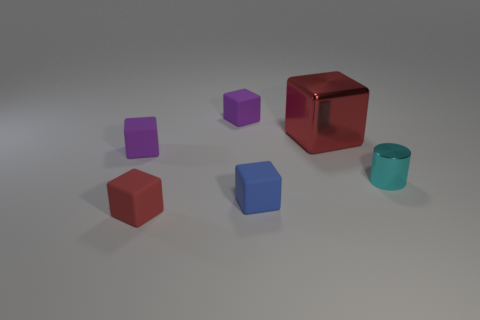Subtract all large red shiny blocks. How many blocks are left? 4 Subtract all purple cylinders. How many purple cubes are left? 2 Subtract 3 blocks. How many blocks are left? 2 Subtract all blue cubes. How many cubes are left? 4 Add 2 tiny purple matte objects. How many objects exist? 8 Subtract all blocks. How many objects are left? 1 Subtract all blue cubes. Subtract all brown cylinders. How many cubes are left? 4 Add 3 small purple matte cubes. How many small purple matte cubes exist? 5 Subtract 0 brown spheres. How many objects are left? 6 Subtract all small cyan metal things. Subtract all tiny brown matte blocks. How many objects are left? 5 